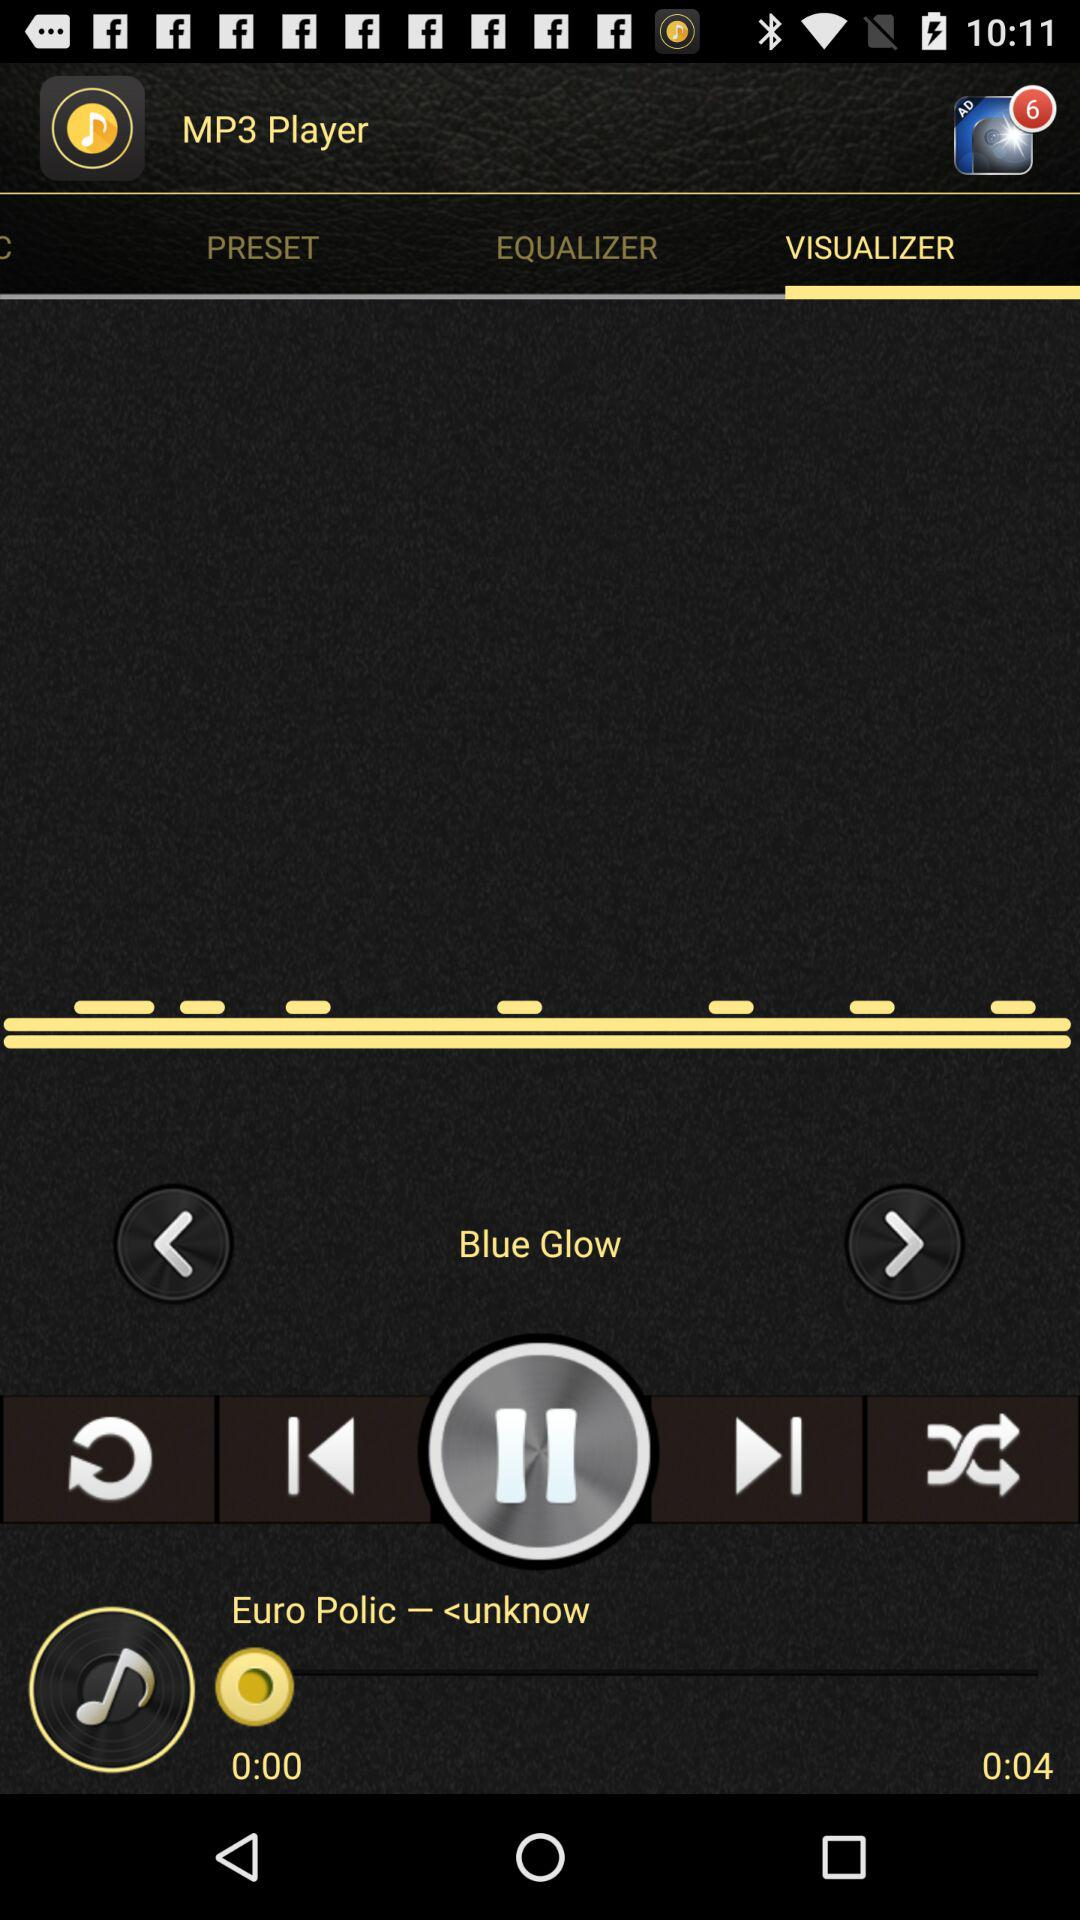How many notifications are there in the advertisement? There are 6 notifications. 